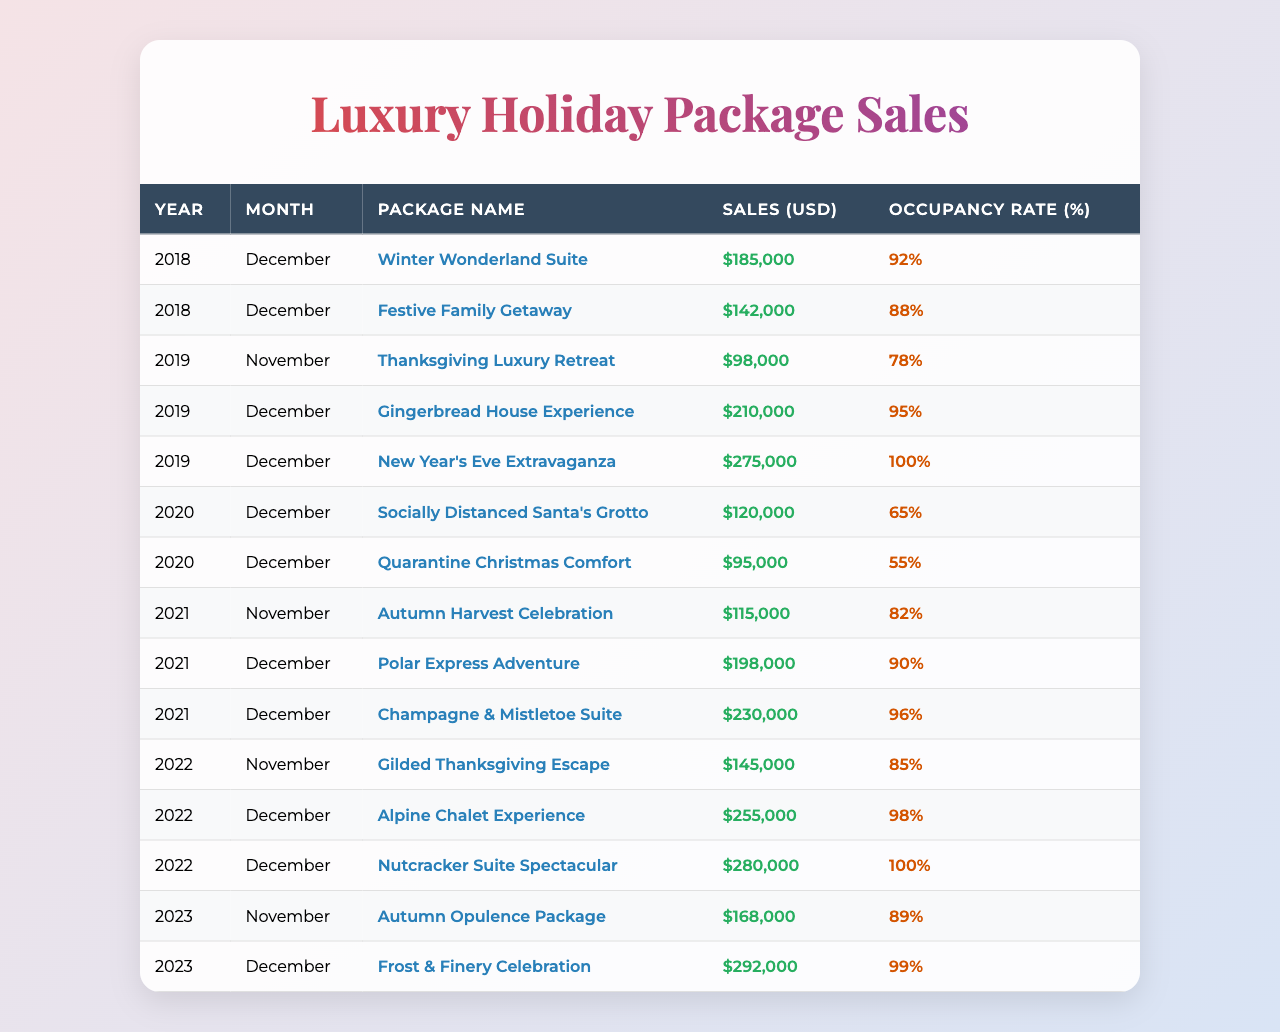What was the total sales for December 2022? The sales for December 2022 were from two packages: Alpine Chalet Experience ($255,000) and Nutcracker Suite Spectacular ($280,000). Adding these gives $255,000 + $280,000 = $535,000.
Answer: $535,000 Which package had the highest sales in December 2019? In December 2019, there were two packages: Gingerbread House Experience ($210,000) and New Year's Eve Extravaganza ($275,000). The higher value is $275,000, so the New Year's Eve Extravaganza had the highest sales.
Answer: New Year's Eve Extravaganza What is the average occupancy rate for December over the past 5 years? The occupancy rates for December from 2018 to 2023 are: 92%, 95%, 100%, 90%, 96%, 98%, 99% (7 rates). Adding them gives 92 + 95 + 100 + 90 + 96 + 98 + 99 = 570. Dividing by 7 gives an average of 570/7 ≈ 81.43.
Answer: 81.43% Did the sales in December 2023 exceed those in December 2022? In December 2023, sales were $292,000, and in December 2022, sales were $535,000. Since $292,000 is less than $535,000, the sales in December 2023 did not exceed those in December 2022.
Answer: No What was the change in sales from December 2021 to December 2022? In December 2021, sales were $198,000 (Polar Express Adventure) + $230,000 (Champagne & Mistletoe Suite) = $428,000. In December 2022, sales were $255,000 (Alpine Chalet Experience) + $280,000 (Nutcracker Suite Spectacular) = $535,000. The change is $535,000 - $428,000 = $107,000 increase.
Answer: $107,000 increase Which month in 2020 had the highest sales, and what was the amount? The data for November 2020 is not available. In December 2020, the sales were from two packages: Socially Distanced Santa's Grotto ($120,000) and Quarantine Christmas Comfort ($95,000). The highest sales for that month is $120,000. Therefore, December 2020 had the highest sales.
Answer: December 2020, $120,000 Was there a year when all packages had an occupancy rate of above 90%? Examining the occupancy rates, in 2019 and 2022, all packages had rates above 90% (100% in December 2019 for two packages and 98%, 100% in December 2022). Yes, there were years.
Answer: Yes What was the total sales for luxury holiday-themed room packages in 2021? For 2021, sales were $115,000 (November) + $198,000 (December for Polar Express) + $230,000 (December for Champagne) = $543,000.
Answer: $543,000 